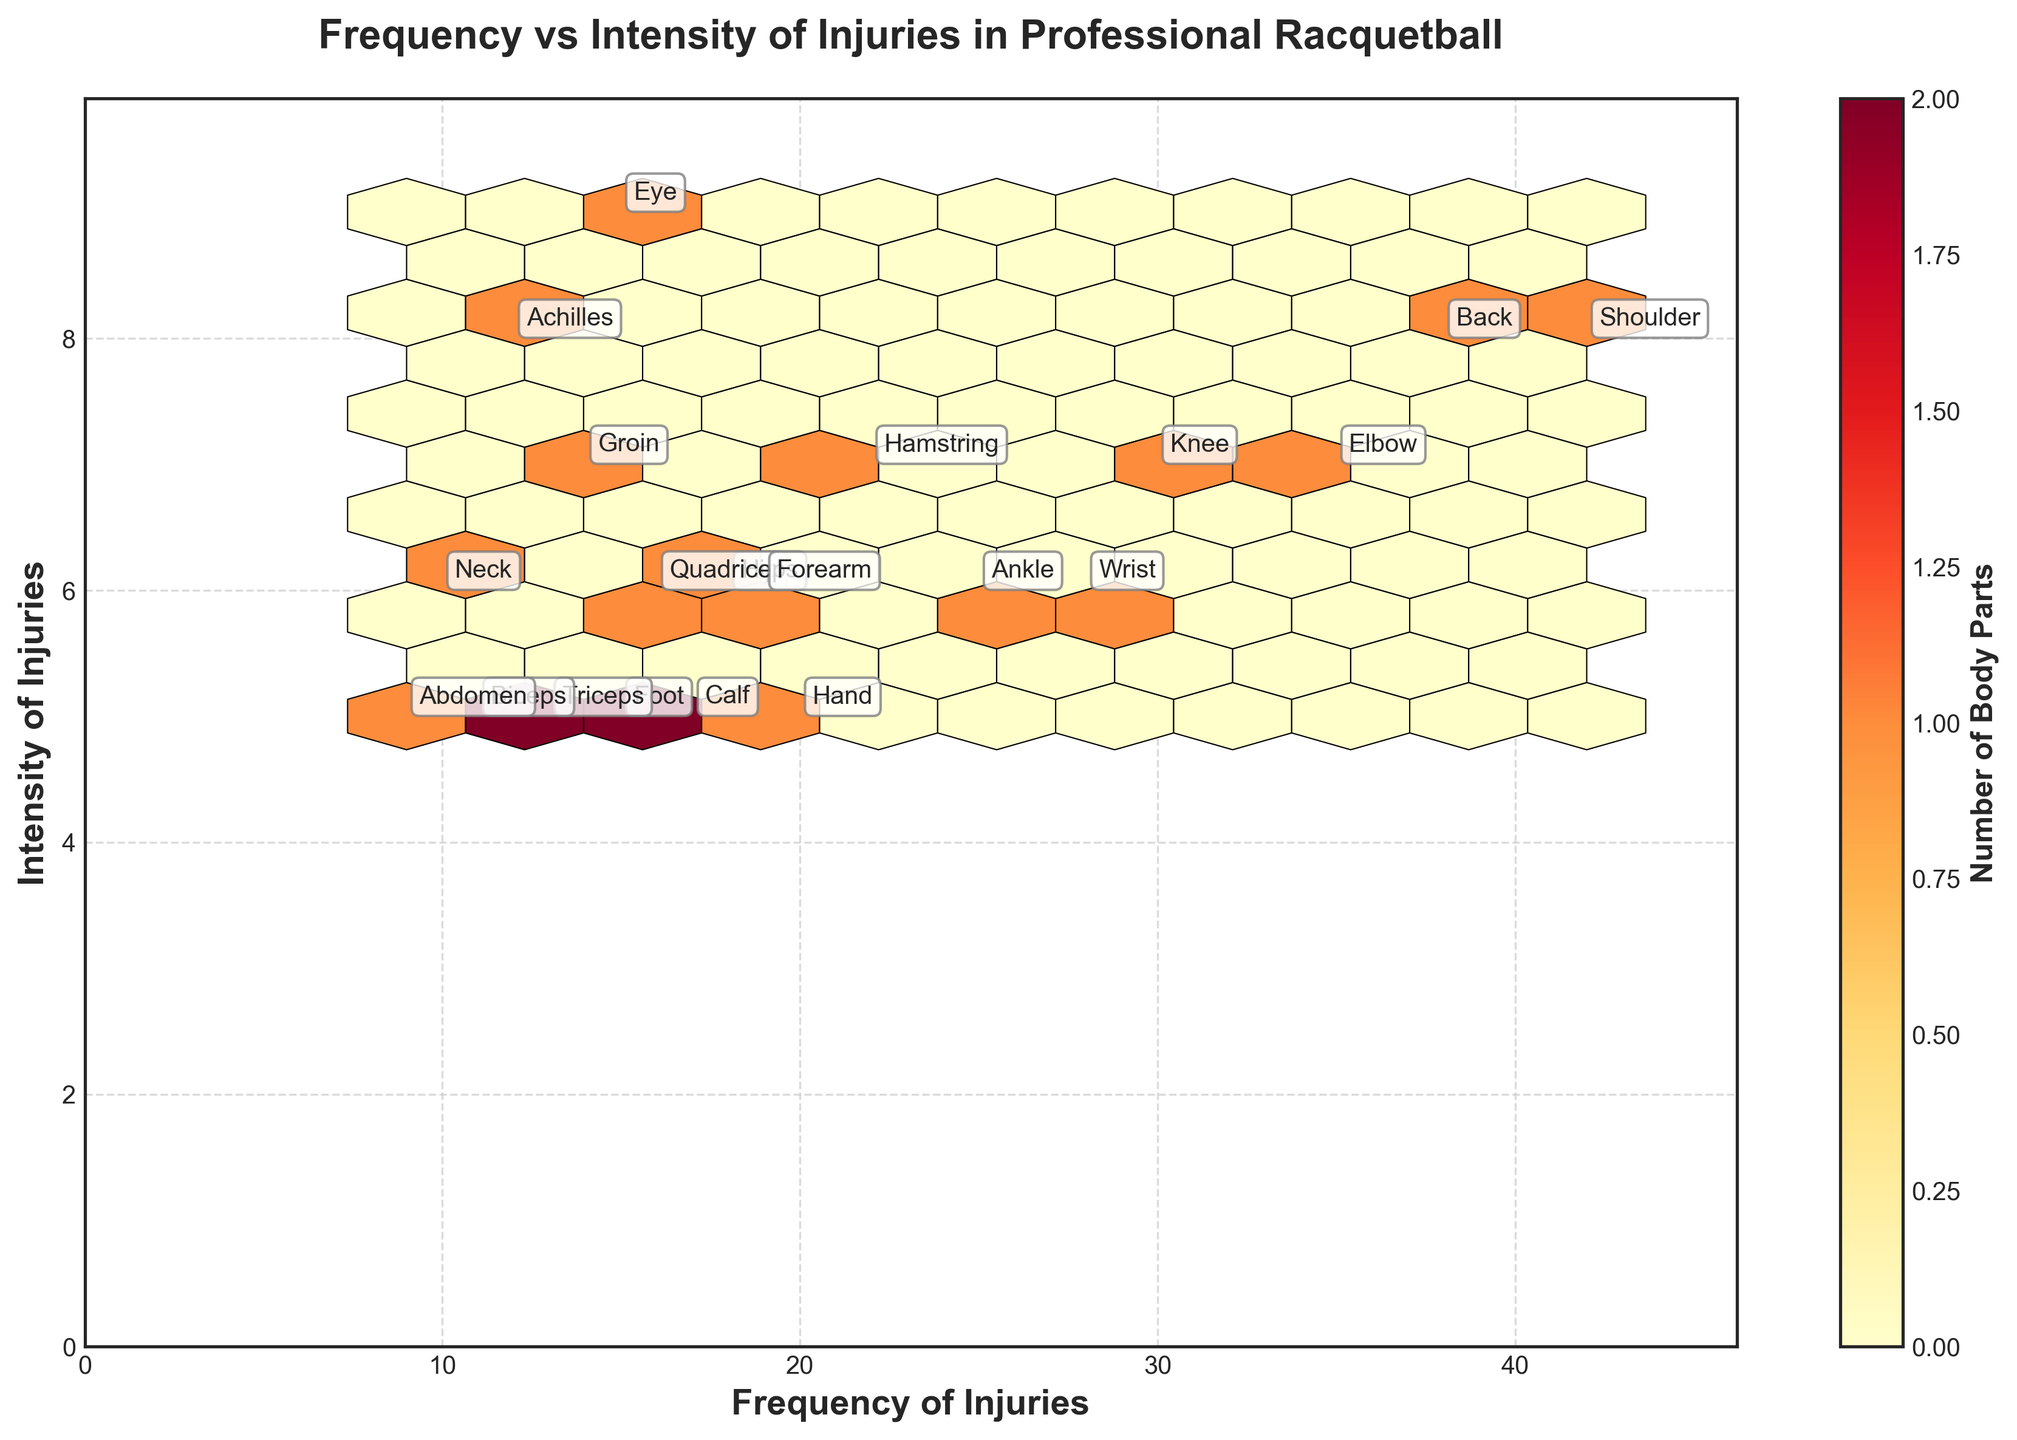How many body parts are plotted in the hexbin plot? Count the labels annotated on the plot for each body part affected by injuries.
Answer: 20 Which body part has the highest frequency of injuries? Look for the body part label placed at the highest value on the frequency axis.
Answer: Shoulder Which body part has the highest injury intensity? Search for the body part label positioned at the highest value on the intensity axis.
Answer: Eye How many body parts have both a frequency and intensity higher than 30 and 7 respectively? Identify the labels positioned in the region where both coordinates are higher than 30 and 7.
Answer: 2 Is the frequency of Shoulder injuries higher than the frequency of Ankle injuries? Compare the frequency value for Shoulder with that for Ankle.
Answer: Yes Which data point represents an injury frequency of 20 and intensity of 5? Look for the body part label corresponding to the coordinates where frequency is 20 and intensity is 5.
Answer: Hand Between Elbow and Back injuries, which one has a higher injury intensity? Compare the intensity values of Elbow and Back.
Answer: Back What's the combined total frequency of injuries for Ankle and Wrist? Add the frequency values for Ankle and Wrist (25 + 28).
Answer: 53 Which body part has a lower intensity: Neck or Achilles? Compare the intensity values for Neck and Achilles.
Answer: Neck Which body part's injuries are represented near the middle of the plot for both frequency and intensity? Identify body part labels that are roughly in the center considering the axis range for both frequency and intensity.
Answer: Knee 